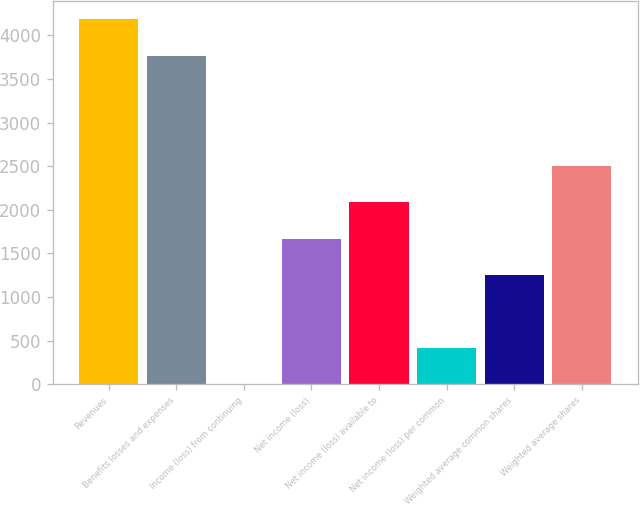Convert chart to OTSL. <chart><loc_0><loc_0><loc_500><loc_500><bar_chart><fcel>Revenues<fcel>Benefits losses and expenses<fcel>Income (loss) from continuing<fcel>Net income (loss)<fcel>Net income (loss) available to<fcel>Net income (loss) per common<fcel>Weighted average common shares<fcel>Weighted average shares<nl><fcel>4184.82<fcel>3768<fcel>0.82<fcel>1668.1<fcel>2084.92<fcel>417.64<fcel>1251.28<fcel>2501.74<nl></chart> 